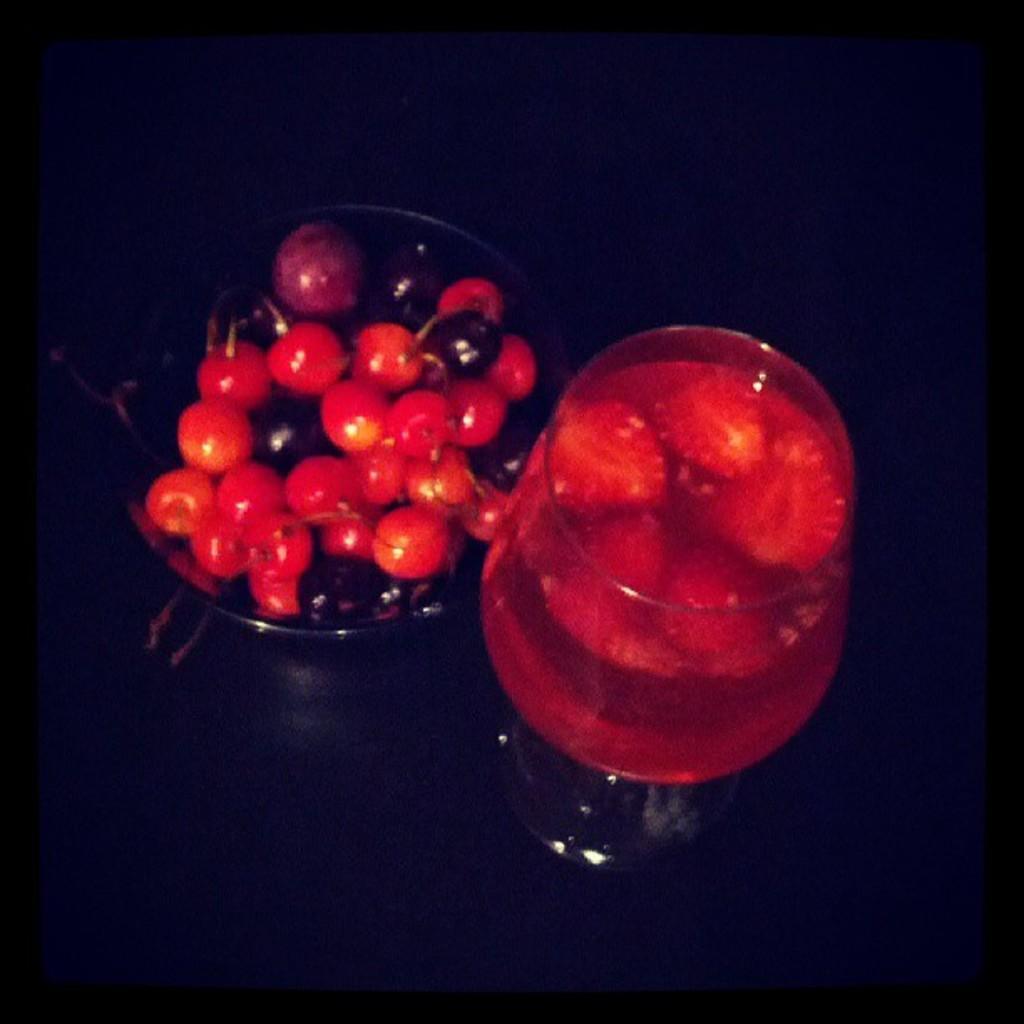Please provide a concise description of this image. On the left side, there are fruits arranged in a glass cup. On the right side, there is a glass filled with juice. And the background is dark in color. 